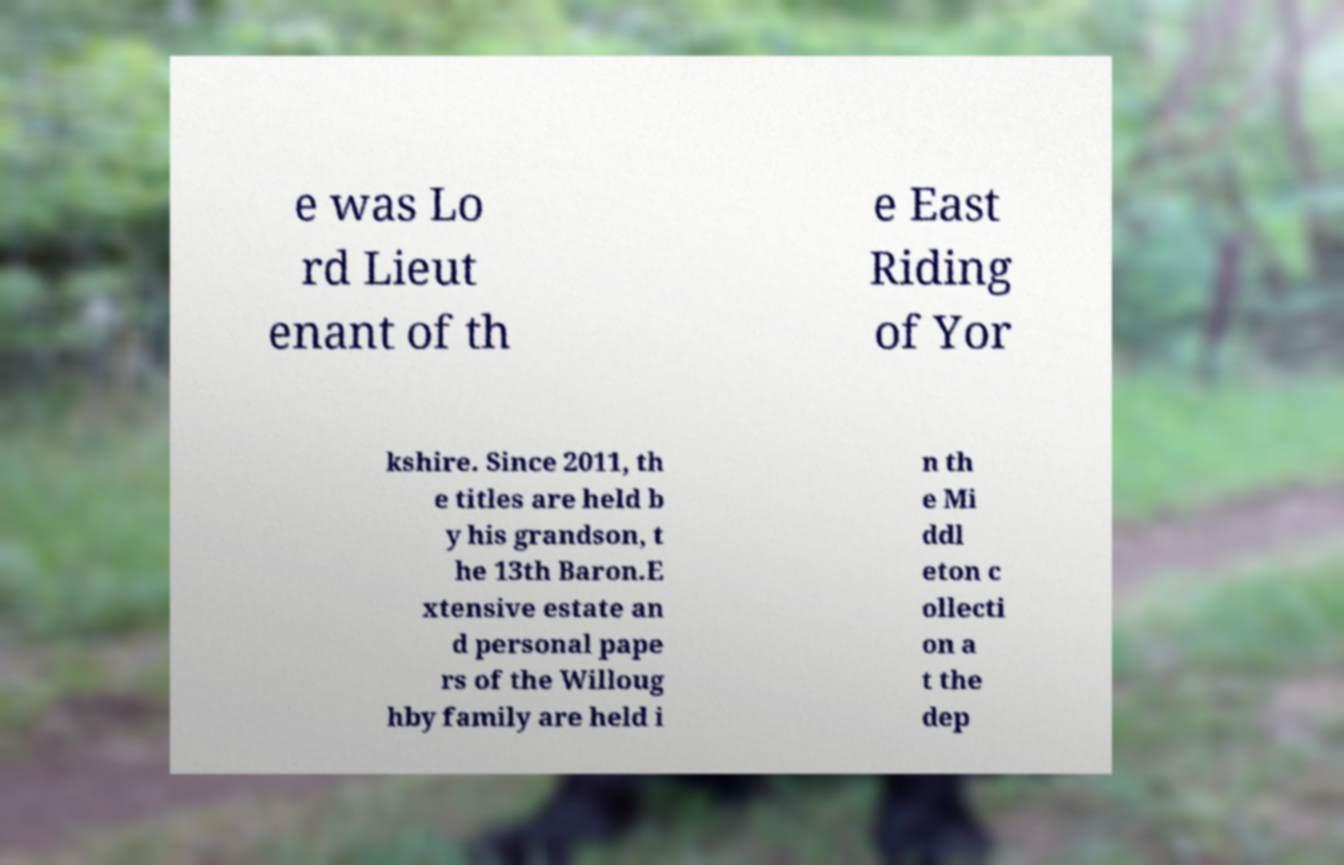What messages or text are displayed in this image? I need them in a readable, typed format. e was Lo rd Lieut enant of th e East Riding of Yor kshire. Since 2011, th e titles are held b y his grandson, t he 13th Baron.E xtensive estate an d personal pape rs of the Willoug hby family are held i n th e Mi ddl eton c ollecti on a t the dep 